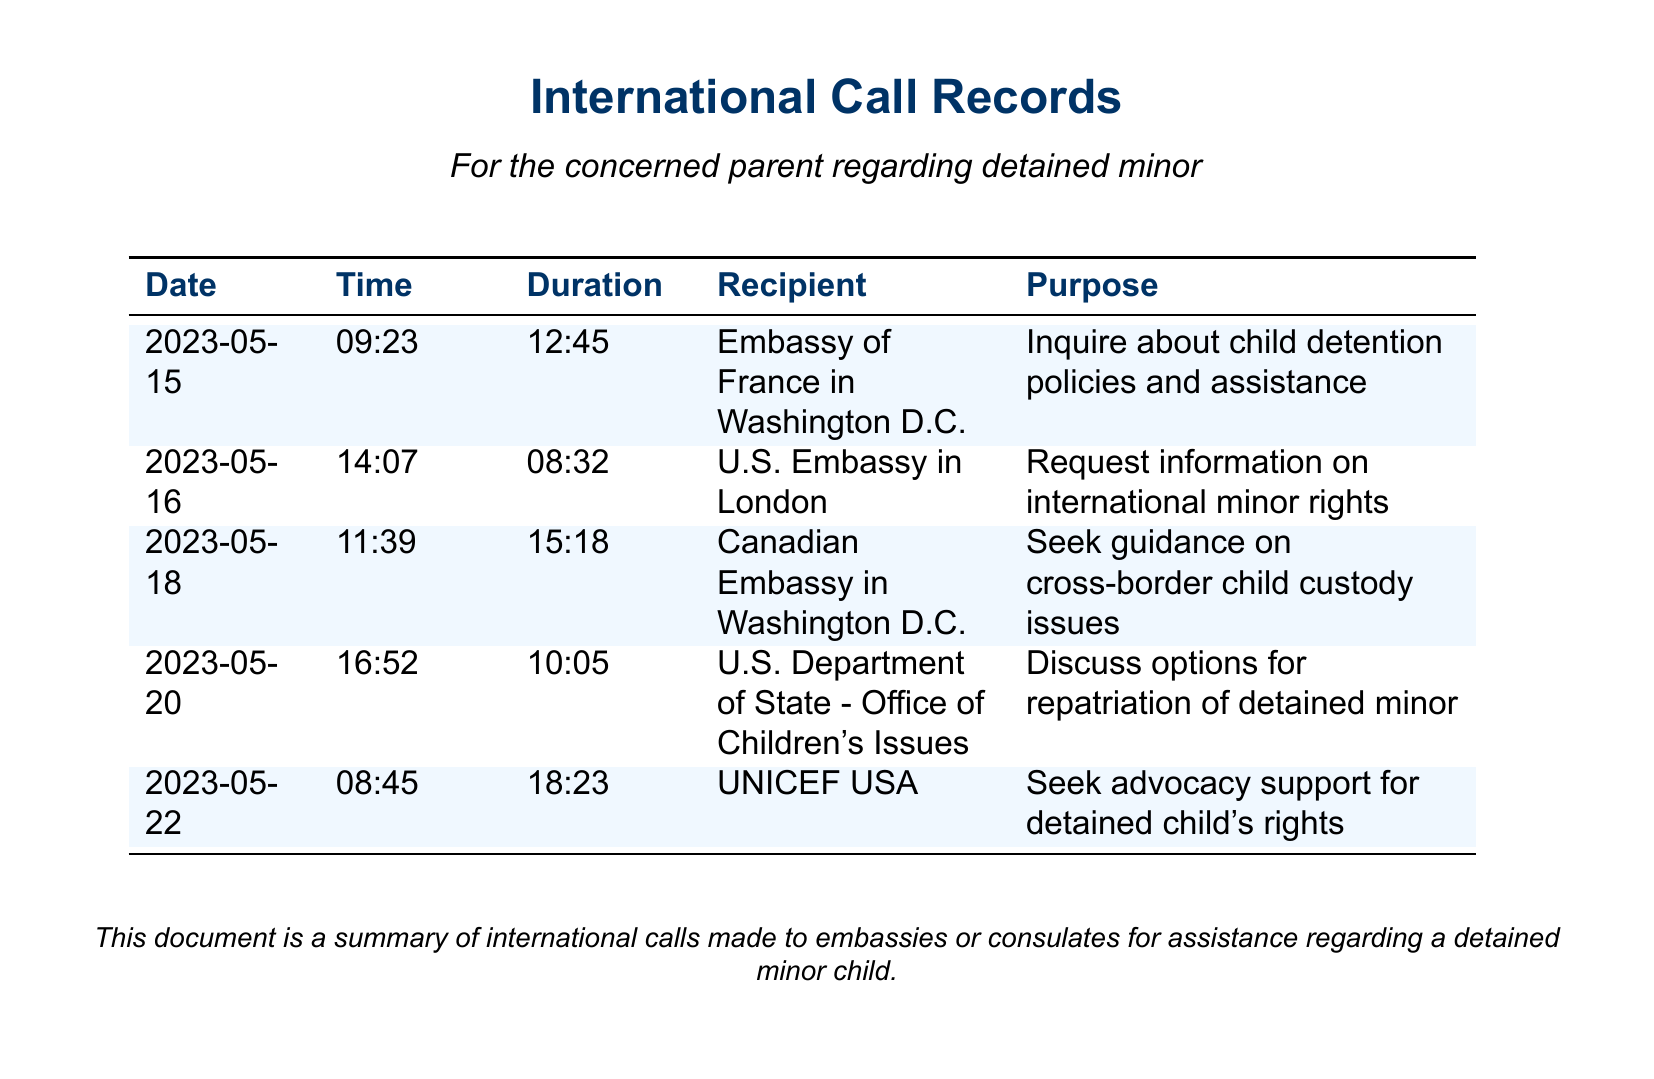What is the date of the first call? The date of the first call is provided in the document, which is listed as the earliest date in the table.
Answer: 2023-05-15 Who was the recipient of the call on May 20? The recipient is found in the row corresponding to the date May 20 in the document.
Answer: U.S. Department of State - Office of Children's Issues What was the duration of the call to UNICEF USA? The duration is indicated in the table under the corresponding recipient's row.
Answer: 18:23 What is the purpose of the call made to the Canadian Embassy? The purpose is detailed in the document under that specific call record.
Answer: Seek guidance on cross-border child custody issues How many calls were made to the U.S. Embassy? To answer this, we count the number of entries in the document where the recipient is associated with the U.S. Embassy.
Answer: 2 What is the total duration of the calls made on May 16 and May 18 combined? This requires summing the durations of the calls on those two dates, which are listed in the document.
Answer: 23:50 Which office did the parent contact for advocacy support? The office is specified in the purpose of the call in the document.
Answer: UNICEF USA What is the common theme of the calls made? The themes can be inferred from the purposes listed for each call in the document.
Answer: Assistance regarding a detained minor child 